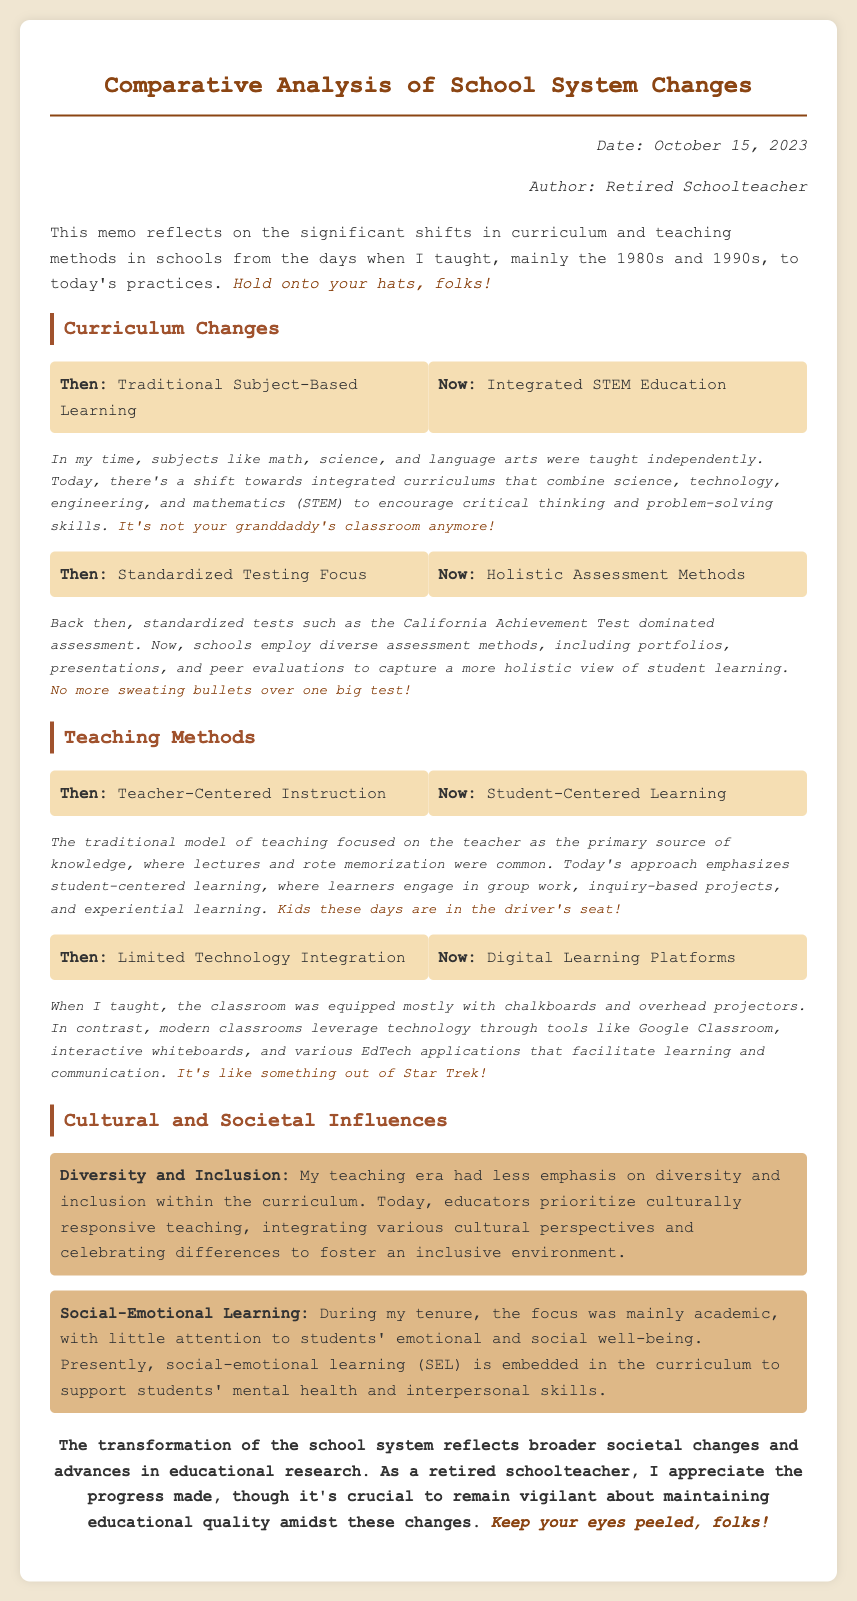What is the date of the memo? The date of the memo is stated at the top in the meta section.
Answer: October 15, 2023 Who is the author of the memo? The author of the memo is identified in the meta section.
Answer: Retired Schoolteacher What did the curriculum focus on in the past? The previous curriculum is discussed in the section on curriculum changes.
Answer: Traditional Subject-Based Learning What type of education is emphasized now? The current curriculum focus is mentioned under curriculum changes.
Answer: Integrated STEM Education What assessment method was favored in the past? The previous assessment method is mentioned in the curriculum section.
Answer: Standardized Testing Focus What assessment methods are used today? The modern assessment methods are listed in the description of today's practices.
Answer: Holistic Assessment Methods What teaching method was prevalent during the author's tenure? The teaching method of the past is highlighted in the teaching methods section.
Answer: Teacher-Centered Instruction What does the current teaching approach emphasize? The current teaching approach is discussed in the teaching methods section.
Answer: Student-Centered Learning What is one cultural influence mentioned? A specific cultural influence is noted in the cultural and societal influences section.
Answer: Diversity and Inclusion What support is now included in the curriculum for students? The support included in the current curriculum is explained in the cultural and societal influences section.
Answer: Social-Emotional Learning 